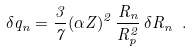<formula> <loc_0><loc_0><loc_500><loc_500>\delta q _ { n } = \frac { 3 } { 7 } ( \alpha Z ) ^ { 2 } \, \frac { R _ { n } } { R ^ { 2 } _ { p } } \, \delta R _ { n } \ .</formula> 